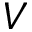Convert formula to latex. <formula><loc_0><loc_0><loc_500><loc_500>V</formula> 